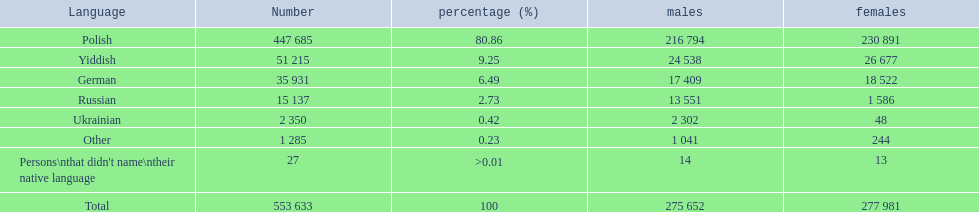What languages are there? Polish, Yiddish, German, Russian, Ukrainian. What numbers speak these languages? 447 685, 51 215, 35 931, 15 137, 2 350. What numbers are not listed as speaking these languages? 1 285, 27. What are the totals of these speakers? 553 633. 